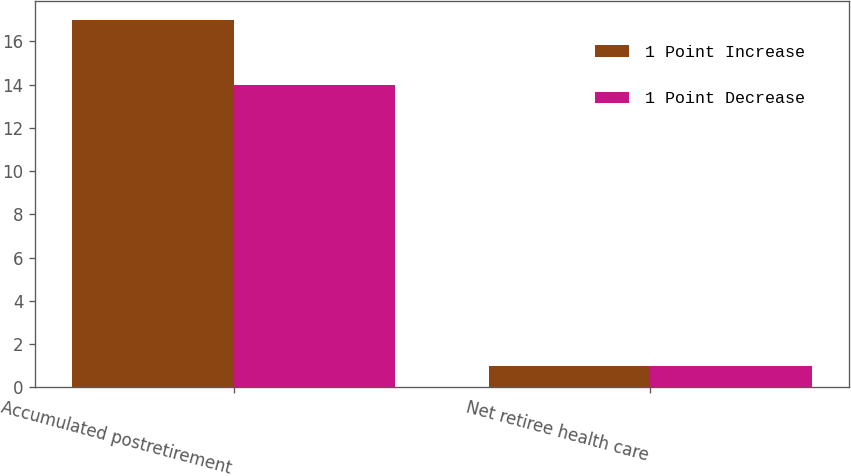<chart> <loc_0><loc_0><loc_500><loc_500><stacked_bar_chart><ecel><fcel>Accumulated postretirement<fcel>Net retiree health care<nl><fcel>1 Point Increase<fcel>17<fcel>1<nl><fcel>1 Point Decrease<fcel>14<fcel>1<nl></chart> 